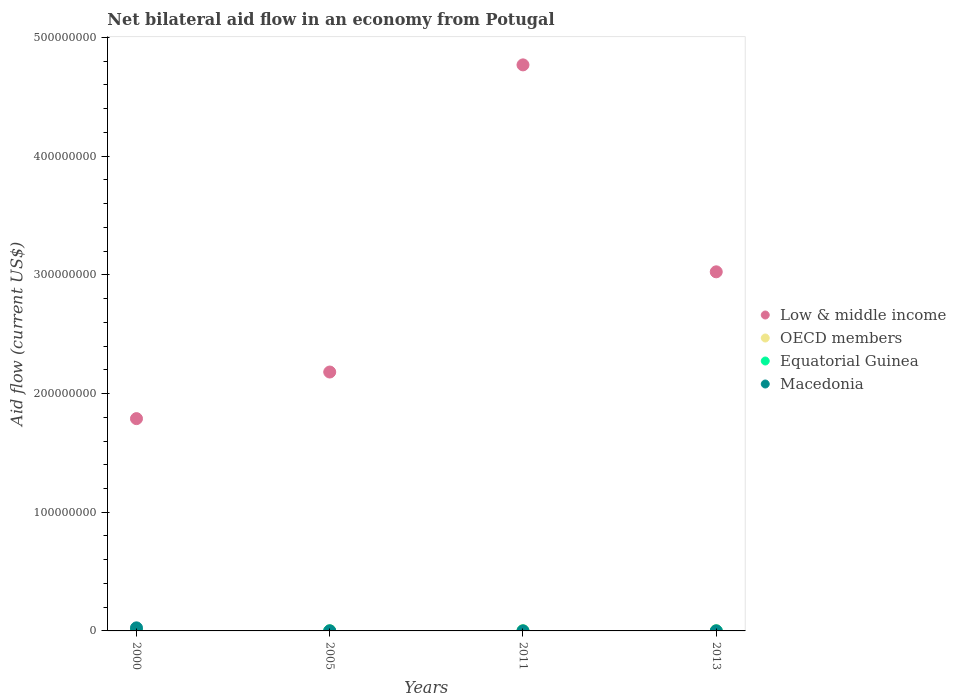Across all years, what is the minimum net bilateral aid flow in OECD members?
Provide a short and direct response. 1.80e+05. In which year was the net bilateral aid flow in OECD members maximum?
Provide a succinct answer. 2000. What is the total net bilateral aid flow in Equatorial Guinea in the graph?
Give a very brief answer. 1.20e+05. What is the difference between the net bilateral aid flow in Low & middle income in 2000 and that in 2011?
Offer a very short reply. -2.98e+08. What is the average net bilateral aid flow in Macedonia per year?
Give a very brief answer. 6.75e+05. In how many years, is the net bilateral aid flow in Macedonia greater than 140000000 US$?
Your answer should be very brief. 0. What is the ratio of the net bilateral aid flow in Macedonia in 2000 to that in 2005?
Your answer should be very brief. 43.17. Is the net bilateral aid flow in OECD members in 2011 less than that in 2013?
Provide a succinct answer. No. Is the difference between the net bilateral aid flow in Macedonia in 2011 and 2013 greater than the difference between the net bilateral aid flow in Equatorial Guinea in 2011 and 2013?
Keep it short and to the point. Yes. What is the difference between the highest and the second highest net bilateral aid flow in Low & middle income?
Make the answer very short. 1.74e+08. What is the difference between the highest and the lowest net bilateral aid flow in Macedonia?
Your answer should be very brief. 2.57e+06. Does the net bilateral aid flow in Macedonia monotonically increase over the years?
Offer a very short reply. No. How many dotlines are there?
Provide a succinct answer. 4. How many years are there in the graph?
Offer a terse response. 4. Are the values on the major ticks of Y-axis written in scientific E-notation?
Make the answer very short. No. Does the graph contain any zero values?
Your answer should be very brief. No. How many legend labels are there?
Your answer should be very brief. 4. What is the title of the graph?
Make the answer very short. Net bilateral aid flow in an economy from Potugal. What is the label or title of the X-axis?
Make the answer very short. Years. What is the label or title of the Y-axis?
Make the answer very short. Aid flow (current US$). What is the Aid flow (current US$) of Low & middle income in 2000?
Your answer should be compact. 1.79e+08. What is the Aid flow (current US$) in Equatorial Guinea in 2000?
Provide a short and direct response. 2.00e+04. What is the Aid flow (current US$) in Macedonia in 2000?
Make the answer very short. 2.59e+06. What is the Aid flow (current US$) in Low & middle income in 2005?
Ensure brevity in your answer.  2.18e+08. What is the Aid flow (current US$) in OECD members in 2005?
Your response must be concise. 1.80e+05. What is the Aid flow (current US$) in Equatorial Guinea in 2005?
Provide a succinct answer. 5.00e+04. What is the Aid flow (current US$) of Low & middle income in 2011?
Give a very brief answer. 4.77e+08. What is the Aid flow (current US$) of OECD members in 2011?
Make the answer very short. 2.40e+05. What is the Aid flow (current US$) of Equatorial Guinea in 2011?
Provide a short and direct response. 10000. What is the Aid flow (current US$) of Low & middle income in 2013?
Ensure brevity in your answer.  3.03e+08. What is the Aid flow (current US$) in OECD members in 2013?
Provide a short and direct response. 2.30e+05. Across all years, what is the maximum Aid flow (current US$) in Low & middle income?
Ensure brevity in your answer.  4.77e+08. Across all years, what is the maximum Aid flow (current US$) in Macedonia?
Your response must be concise. 2.59e+06. Across all years, what is the minimum Aid flow (current US$) in Low & middle income?
Offer a terse response. 1.79e+08. Across all years, what is the minimum Aid flow (current US$) in Equatorial Guinea?
Provide a short and direct response. 10000. What is the total Aid flow (current US$) of Low & middle income in the graph?
Provide a short and direct response. 1.18e+09. What is the total Aid flow (current US$) of Macedonia in the graph?
Your answer should be compact. 2.70e+06. What is the difference between the Aid flow (current US$) of Low & middle income in 2000 and that in 2005?
Your response must be concise. -3.93e+07. What is the difference between the Aid flow (current US$) of Macedonia in 2000 and that in 2005?
Offer a terse response. 2.53e+06. What is the difference between the Aid flow (current US$) of Low & middle income in 2000 and that in 2011?
Offer a terse response. -2.98e+08. What is the difference between the Aid flow (current US$) of OECD members in 2000 and that in 2011?
Keep it short and to the point. 1.10e+05. What is the difference between the Aid flow (current US$) of Macedonia in 2000 and that in 2011?
Offer a terse response. 2.57e+06. What is the difference between the Aid flow (current US$) of Low & middle income in 2000 and that in 2013?
Make the answer very short. -1.24e+08. What is the difference between the Aid flow (current US$) of OECD members in 2000 and that in 2013?
Offer a very short reply. 1.20e+05. What is the difference between the Aid flow (current US$) of Equatorial Guinea in 2000 and that in 2013?
Provide a succinct answer. -2.00e+04. What is the difference between the Aid flow (current US$) of Macedonia in 2000 and that in 2013?
Ensure brevity in your answer.  2.56e+06. What is the difference between the Aid flow (current US$) in Low & middle income in 2005 and that in 2011?
Give a very brief answer. -2.59e+08. What is the difference between the Aid flow (current US$) of OECD members in 2005 and that in 2011?
Offer a terse response. -6.00e+04. What is the difference between the Aid flow (current US$) in Equatorial Guinea in 2005 and that in 2011?
Keep it short and to the point. 4.00e+04. What is the difference between the Aid flow (current US$) in Low & middle income in 2005 and that in 2013?
Give a very brief answer. -8.44e+07. What is the difference between the Aid flow (current US$) in Macedonia in 2005 and that in 2013?
Provide a short and direct response. 3.00e+04. What is the difference between the Aid flow (current US$) of Low & middle income in 2011 and that in 2013?
Provide a short and direct response. 1.74e+08. What is the difference between the Aid flow (current US$) in OECD members in 2011 and that in 2013?
Your response must be concise. 10000. What is the difference between the Aid flow (current US$) in Equatorial Guinea in 2011 and that in 2013?
Provide a short and direct response. -3.00e+04. What is the difference between the Aid flow (current US$) in Macedonia in 2011 and that in 2013?
Your response must be concise. -10000. What is the difference between the Aid flow (current US$) in Low & middle income in 2000 and the Aid flow (current US$) in OECD members in 2005?
Your response must be concise. 1.79e+08. What is the difference between the Aid flow (current US$) of Low & middle income in 2000 and the Aid flow (current US$) of Equatorial Guinea in 2005?
Make the answer very short. 1.79e+08. What is the difference between the Aid flow (current US$) in Low & middle income in 2000 and the Aid flow (current US$) in Macedonia in 2005?
Your response must be concise. 1.79e+08. What is the difference between the Aid flow (current US$) in OECD members in 2000 and the Aid flow (current US$) in Equatorial Guinea in 2005?
Provide a short and direct response. 3.00e+05. What is the difference between the Aid flow (current US$) in Equatorial Guinea in 2000 and the Aid flow (current US$) in Macedonia in 2005?
Your answer should be very brief. -4.00e+04. What is the difference between the Aid flow (current US$) of Low & middle income in 2000 and the Aid flow (current US$) of OECD members in 2011?
Your answer should be very brief. 1.79e+08. What is the difference between the Aid flow (current US$) in Low & middle income in 2000 and the Aid flow (current US$) in Equatorial Guinea in 2011?
Keep it short and to the point. 1.79e+08. What is the difference between the Aid flow (current US$) in Low & middle income in 2000 and the Aid flow (current US$) in Macedonia in 2011?
Ensure brevity in your answer.  1.79e+08. What is the difference between the Aid flow (current US$) in Low & middle income in 2000 and the Aid flow (current US$) in OECD members in 2013?
Offer a very short reply. 1.79e+08. What is the difference between the Aid flow (current US$) in Low & middle income in 2000 and the Aid flow (current US$) in Equatorial Guinea in 2013?
Your answer should be very brief. 1.79e+08. What is the difference between the Aid flow (current US$) in Low & middle income in 2000 and the Aid flow (current US$) in Macedonia in 2013?
Give a very brief answer. 1.79e+08. What is the difference between the Aid flow (current US$) of OECD members in 2000 and the Aid flow (current US$) of Equatorial Guinea in 2013?
Provide a short and direct response. 3.10e+05. What is the difference between the Aid flow (current US$) in Low & middle income in 2005 and the Aid flow (current US$) in OECD members in 2011?
Your response must be concise. 2.18e+08. What is the difference between the Aid flow (current US$) in Low & middle income in 2005 and the Aid flow (current US$) in Equatorial Guinea in 2011?
Provide a short and direct response. 2.18e+08. What is the difference between the Aid flow (current US$) in Low & middle income in 2005 and the Aid flow (current US$) in Macedonia in 2011?
Your answer should be very brief. 2.18e+08. What is the difference between the Aid flow (current US$) in OECD members in 2005 and the Aid flow (current US$) in Equatorial Guinea in 2011?
Offer a very short reply. 1.70e+05. What is the difference between the Aid flow (current US$) in OECD members in 2005 and the Aid flow (current US$) in Macedonia in 2011?
Ensure brevity in your answer.  1.60e+05. What is the difference between the Aid flow (current US$) of Equatorial Guinea in 2005 and the Aid flow (current US$) of Macedonia in 2011?
Keep it short and to the point. 3.00e+04. What is the difference between the Aid flow (current US$) of Low & middle income in 2005 and the Aid flow (current US$) of OECD members in 2013?
Make the answer very short. 2.18e+08. What is the difference between the Aid flow (current US$) in Low & middle income in 2005 and the Aid flow (current US$) in Equatorial Guinea in 2013?
Offer a terse response. 2.18e+08. What is the difference between the Aid flow (current US$) in Low & middle income in 2005 and the Aid flow (current US$) in Macedonia in 2013?
Give a very brief answer. 2.18e+08. What is the difference between the Aid flow (current US$) in OECD members in 2005 and the Aid flow (current US$) in Equatorial Guinea in 2013?
Ensure brevity in your answer.  1.40e+05. What is the difference between the Aid flow (current US$) in Equatorial Guinea in 2005 and the Aid flow (current US$) in Macedonia in 2013?
Your answer should be compact. 2.00e+04. What is the difference between the Aid flow (current US$) in Low & middle income in 2011 and the Aid flow (current US$) in OECD members in 2013?
Your response must be concise. 4.77e+08. What is the difference between the Aid flow (current US$) in Low & middle income in 2011 and the Aid flow (current US$) in Equatorial Guinea in 2013?
Provide a succinct answer. 4.77e+08. What is the difference between the Aid flow (current US$) of Low & middle income in 2011 and the Aid flow (current US$) of Macedonia in 2013?
Your response must be concise. 4.77e+08. What is the difference between the Aid flow (current US$) in OECD members in 2011 and the Aid flow (current US$) in Equatorial Guinea in 2013?
Keep it short and to the point. 2.00e+05. What is the difference between the Aid flow (current US$) of OECD members in 2011 and the Aid flow (current US$) of Macedonia in 2013?
Provide a short and direct response. 2.10e+05. What is the average Aid flow (current US$) in Low & middle income per year?
Provide a succinct answer. 2.94e+08. What is the average Aid flow (current US$) of Macedonia per year?
Give a very brief answer. 6.75e+05. In the year 2000, what is the difference between the Aid flow (current US$) of Low & middle income and Aid flow (current US$) of OECD members?
Ensure brevity in your answer.  1.79e+08. In the year 2000, what is the difference between the Aid flow (current US$) of Low & middle income and Aid flow (current US$) of Equatorial Guinea?
Offer a very short reply. 1.79e+08. In the year 2000, what is the difference between the Aid flow (current US$) of Low & middle income and Aid flow (current US$) of Macedonia?
Make the answer very short. 1.76e+08. In the year 2000, what is the difference between the Aid flow (current US$) in OECD members and Aid flow (current US$) in Equatorial Guinea?
Ensure brevity in your answer.  3.30e+05. In the year 2000, what is the difference between the Aid flow (current US$) of OECD members and Aid flow (current US$) of Macedonia?
Make the answer very short. -2.24e+06. In the year 2000, what is the difference between the Aid flow (current US$) in Equatorial Guinea and Aid flow (current US$) in Macedonia?
Provide a short and direct response. -2.57e+06. In the year 2005, what is the difference between the Aid flow (current US$) of Low & middle income and Aid flow (current US$) of OECD members?
Offer a very short reply. 2.18e+08. In the year 2005, what is the difference between the Aid flow (current US$) of Low & middle income and Aid flow (current US$) of Equatorial Guinea?
Your response must be concise. 2.18e+08. In the year 2005, what is the difference between the Aid flow (current US$) of Low & middle income and Aid flow (current US$) of Macedonia?
Your answer should be very brief. 2.18e+08. In the year 2011, what is the difference between the Aid flow (current US$) in Low & middle income and Aid flow (current US$) in OECD members?
Keep it short and to the point. 4.77e+08. In the year 2011, what is the difference between the Aid flow (current US$) in Low & middle income and Aid flow (current US$) in Equatorial Guinea?
Make the answer very short. 4.77e+08. In the year 2011, what is the difference between the Aid flow (current US$) of Low & middle income and Aid flow (current US$) of Macedonia?
Offer a very short reply. 4.77e+08. In the year 2011, what is the difference between the Aid flow (current US$) of OECD members and Aid flow (current US$) of Equatorial Guinea?
Provide a succinct answer. 2.30e+05. In the year 2011, what is the difference between the Aid flow (current US$) of OECD members and Aid flow (current US$) of Macedonia?
Your answer should be very brief. 2.20e+05. In the year 2011, what is the difference between the Aid flow (current US$) of Equatorial Guinea and Aid flow (current US$) of Macedonia?
Make the answer very short. -10000. In the year 2013, what is the difference between the Aid flow (current US$) in Low & middle income and Aid flow (current US$) in OECD members?
Your answer should be very brief. 3.02e+08. In the year 2013, what is the difference between the Aid flow (current US$) in Low & middle income and Aid flow (current US$) in Equatorial Guinea?
Ensure brevity in your answer.  3.03e+08. In the year 2013, what is the difference between the Aid flow (current US$) in Low & middle income and Aid flow (current US$) in Macedonia?
Offer a terse response. 3.03e+08. What is the ratio of the Aid flow (current US$) of Low & middle income in 2000 to that in 2005?
Keep it short and to the point. 0.82. What is the ratio of the Aid flow (current US$) of OECD members in 2000 to that in 2005?
Offer a terse response. 1.94. What is the ratio of the Aid flow (current US$) in Equatorial Guinea in 2000 to that in 2005?
Your answer should be very brief. 0.4. What is the ratio of the Aid flow (current US$) in Macedonia in 2000 to that in 2005?
Keep it short and to the point. 43.17. What is the ratio of the Aid flow (current US$) of OECD members in 2000 to that in 2011?
Your answer should be very brief. 1.46. What is the ratio of the Aid flow (current US$) of Equatorial Guinea in 2000 to that in 2011?
Keep it short and to the point. 2. What is the ratio of the Aid flow (current US$) in Macedonia in 2000 to that in 2011?
Keep it short and to the point. 129.5. What is the ratio of the Aid flow (current US$) of Low & middle income in 2000 to that in 2013?
Your answer should be compact. 0.59. What is the ratio of the Aid flow (current US$) in OECD members in 2000 to that in 2013?
Your answer should be very brief. 1.52. What is the ratio of the Aid flow (current US$) of Macedonia in 2000 to that in 2013?
Your answer should be very brief. 86.33. What is the ratio of the Aid flow (current US$) of Low & middle income in 2005 to that in 2011?
Give a very brief answer. 0.46. What is the ratio of the Aid flow (current US$) of OECD members in 2005 to that in 2011?
Give a very brief answer. 0.75. What is the ratio of the Aid flow (current US$) of Equatorial Guinea in 2005 to that in 2011?
Your response must be concise. 5. What is the ratio of the Aid flow (current US$) of Low & middle income in 2005 to that in 2013?
Give a very brief answer. 0.72. What is the ratio of the Aid flow (current US$) of OECD members in 2005 to that in 2013?
Offer a very short reply. 0.78. What is the ratio of the Aid flow (current US$) in Equatorial Guinea in 2005 to that in 2013?
Your answer should be compact. 1.25. What is the ratio of the Aid flow (current US$) of Low & middle income in 2011 to that in 2013?
Offer a terse response. 1.58. What is the ratio of the Aid flow (current US$) of OECD members in 2011 to that in 2013?
Make the answer very short. 1.04. What is the ratio of the Aid flow (current US$) in Equatorial Guinea in 2011 to that in 2013?
Your response must be concise. 0.25. What is the difference between the highest and the second highest Aid flow (current US$) in Low & middle income?
Make the answer very short. 1.74e+08. What is the difference between the highest and the second highest Aid flow (current US$) of Equatorial Guinea?
Keep it short and to the point. 10000. What is the difference between the highest and the second highest Aid flow (current US$) in Macedonia?
Provide a short and direct response. 2.53e+06. What is the difference between the highest and the lowest Aid flow (current US$) of Low & middle income?
Give a very brief answer. 2.98e+08. What is the difference between the highest and the lowest Aid flow (current US$) of Macedonia?
Offer a terse response. 2.57e+06. 